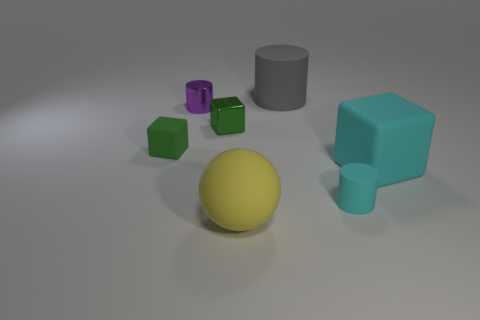Is there a blue thing of the same size as the cyan cube?
Your response must be concise. No. There is a gray thing; what shape is it?
Provide a short and direct response. Cylinder. How many blocks are matte objects or green shiny things?
Your answer should be very brief. 3. Are there an equal number of purple objects that are in front of the yellow rubber object and rubber blocks that are behind the big cyan block?
Offer a very short reply. No. What number of tiny rubber objects are in front of the tiny matte thing behind the tiny matte thing that is right of the big yellow sphere?
Offer a very short reply. 1. What is the shape of the rubber object that is the same color as the shiny cube?
Provide a succinct answer. Cube. Is the color of the large block the same as the cylinder in front of the tiny purple cylinder?
Your answer should be very brief. Yes. Are there more blocks that are to the left of the big matte cube than tiny cyan matte spheres?
Offer a terse response. Yes. What number of objects are objects to the left of the large matte cylinder or objects right of the big yellow rubber thing?
Provide a short and direct response. 7. There is a green thing that is the same material as the small purple cylinder; what is its size?
Offer a very short reply. Small. 